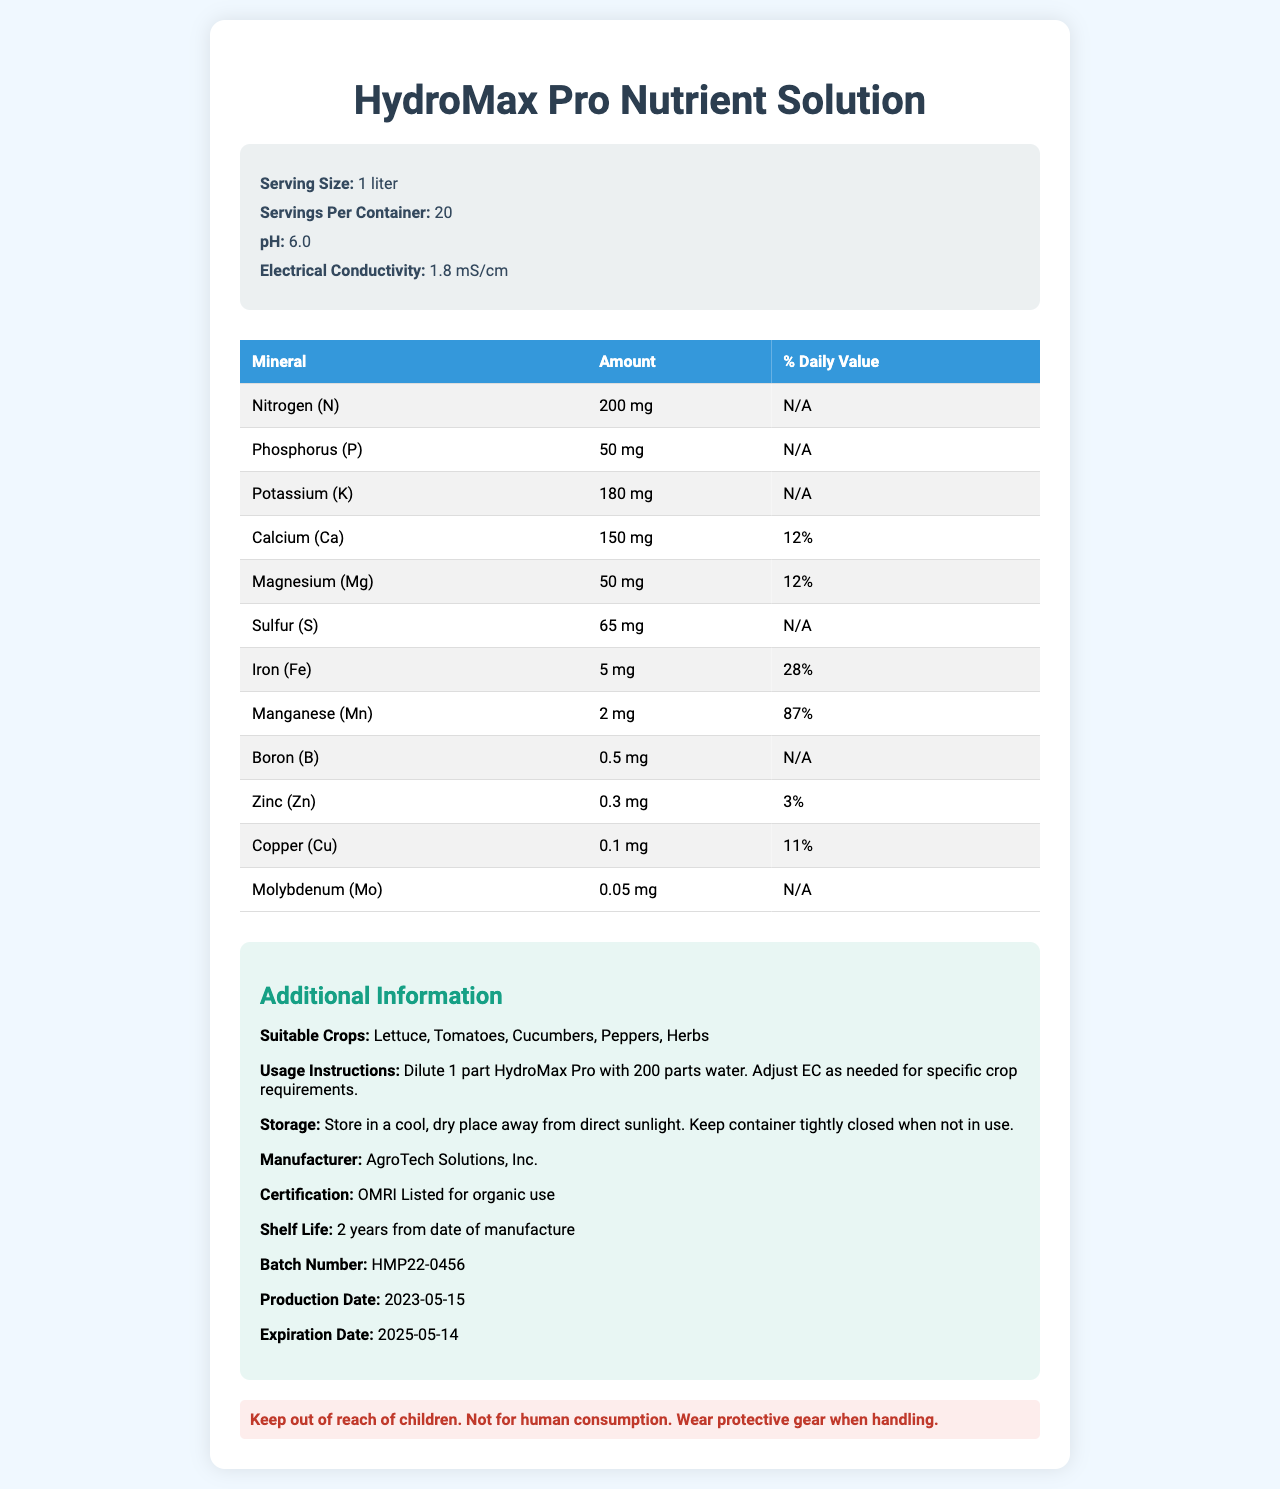what is the serving size of the HydroMax Pro Nutrient Solution? The serving size is clearly listed in the document under the "Serving Size" section of the product info.
Answer: 1 liter how many servings are there per container? The number of servings per container is mentioned as 20 in the "Servings Per Container" section of the product info.
Answer: 20 what is the pH level of the HydroMax Pro Nutrient Solution? The pH level is listed as 6.0 in the "pH" section of the product info.
Answer: 6.0 which mineral has the highest percentage of daily value? Manganese has the highest percentage of daily value at 87%, as shown in the % Daily Value column of the minerals table.
Answer: Manganese (87%) what is the electrical conductivity of the solution? The electrical conductivity is mentioned in the "Electrical Conductivity" section of the product info.
Answer: 1.8 mS/cm which crops are suitable for HydroMax Pro Nutrient Solution use? A. Lettuce, Tomatoes, Carrots B. Cucumbers, Peppers, Herbs C. All of the above The suitable crops listed for the HydroMax Pro Nutrient Solution are Lettuce, Tomatoes, Cucumbers, Peppers, and Herbs, covering all options.
Answer: C. All of the above which mineral is present in the smallest quantity? (Choose the correct answer) i. Zinc ii. Boron iii. Copper iv. Molybdenum Molybdenum is present in the smallest quantity at 0.05 mg, as listed in the mineral content table.
Answer: iv. Molybdenum is the HydroMax Pro Nutrient Solution OMRI listed for organic use? The certification section states that the product is OMRI Listed for organic use.
Answer: Yes is there any storage instruction for HydroMax Pro Nutrient Solution being mentioned? The storage instruction is mentioned: "Store in a cool, dry place away from direct sunlight. Keep container tightly closed when not in use."
Answer: Yes summarize the main idea of the HydroMax Pro Nutrient Solution document? The main idea of the document is to present comprehensive information about the HydroMax Pro Nutrient Solution, aimed at optimizing crop yields for specific suitable crops by providing proper dilution and usage instructions and highlighting its mineral composition and safety measures.
Answer: The document provides detailed nutrition facts for HydroMax Pro Nutrient Solution including serving size, servings per container, pH, electrical conductivity, mineral content with amounts and daily values, suitable crops, usage instructions, storage, manufacturer information, certification, warning, shelf life, batch number, production date, and expiration date. what is the recommended dilution ratio for using HydroMax Pro Nutrient Solution? The dilution ratio is found in the "Usage Instructions" section which states, "Dilute 1 part HydroMax Pro with 200 parts water."
Answer: Dilute 1 part HydroMax Pro with 200 parts water can the exact total nitrogen content in a container be determined from the document? The document only provides the nitrogen content per serving (200 mg) and the number of servings per container (20), so the exact total amount isn't directly listed but could be calculated.
Answer: No 